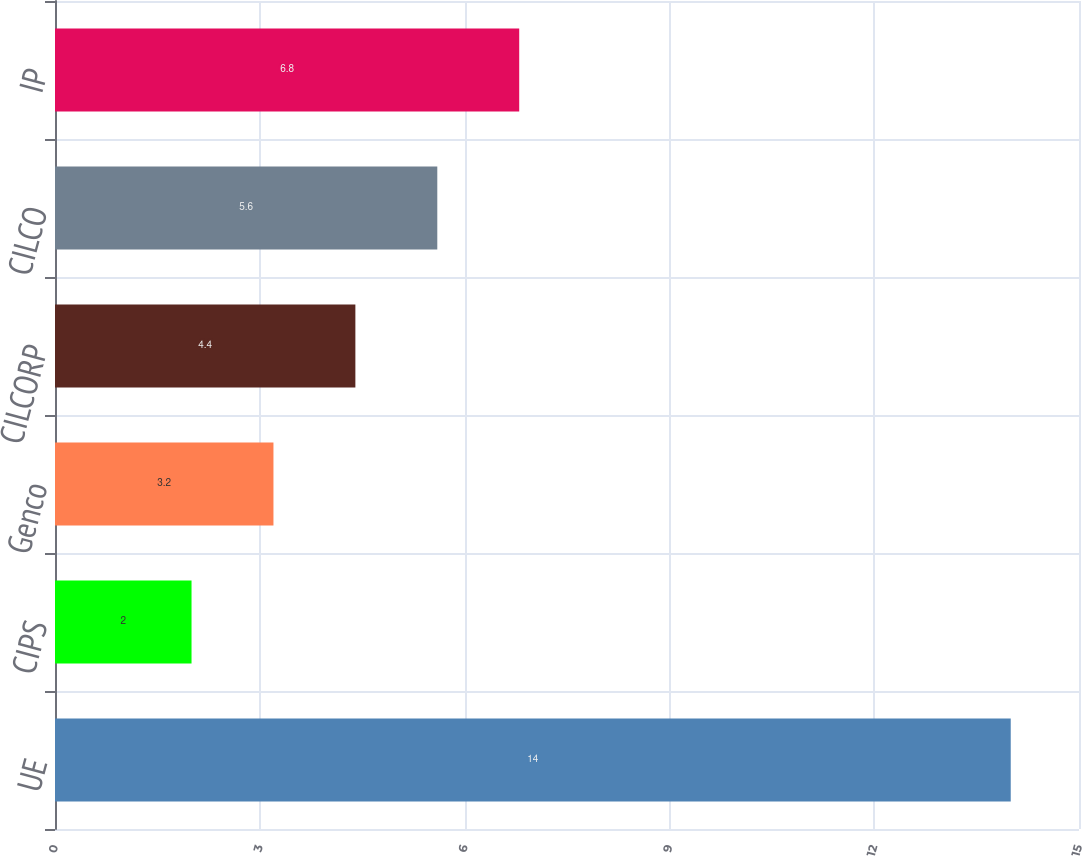<chart> <loc_0><loc_0><loc_500><loc_500><bar_chart><fcel>UE<fcel>CIPS<fcel>Genco<fcel>CILCORP<fcel>CILCO<fcel>IP<nl><fcel>14<fcel>2<fcel>3.2<fcel>4.4<fcel>5.6<fcel>6.8<nl></chart> 